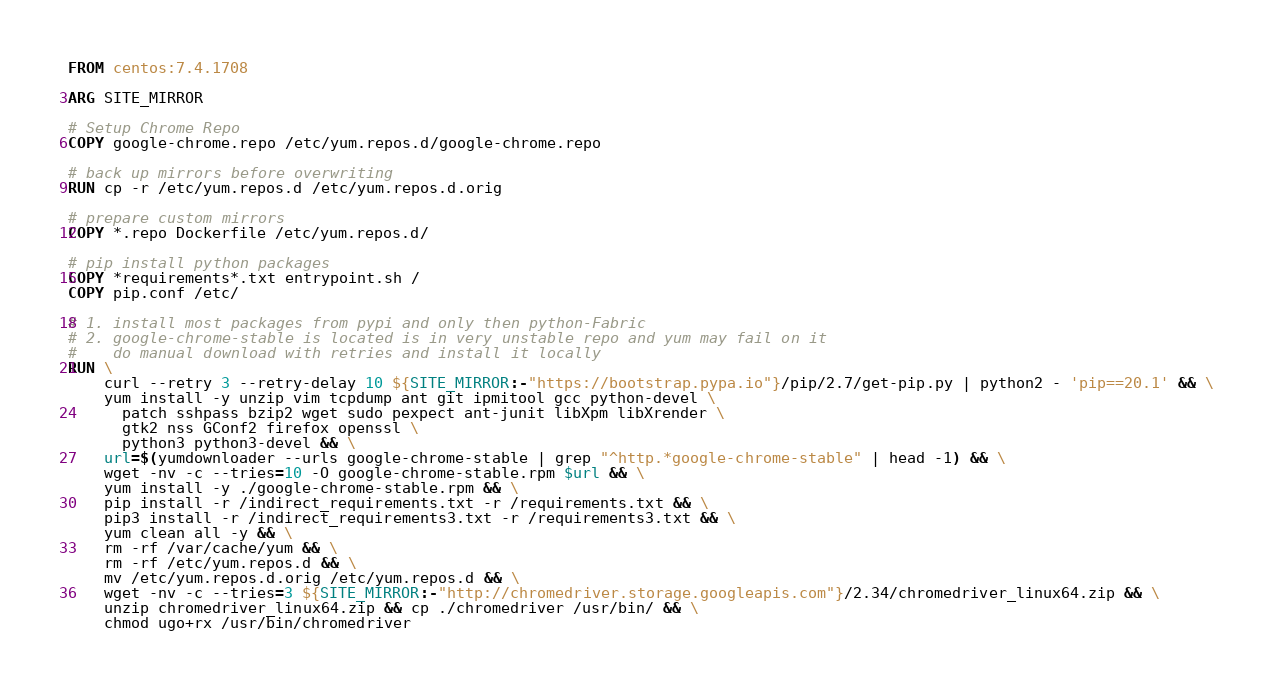<code> <loc_0><loc_0><loc_500><loc_500><_Dockerfile_>FROM centos:7.4.1708

ARG SITE_MIRROR

# Setup Chrome Repo
COPY google-chrome.repo /etc/yum.repos.d/google-chrome.repo

# back up mirrors before overwriting
RUN cp -r /etc/yum.repos.d /etc/yum.repos.d.orig

# prepare custom mirrors
COPY *.repo Dockerfile /etc/yum.repos.d/

# pip install python packages
COPY *requirements*.txt entrypoint.sh /
COPY pip.conf /etc/

# 1. install most packages from pypi and only then python-Fabric
# 2. google-chrome-stable is located is in very unstable repo and yum may fail on it
#    do manual download with retries and install it locally
RUN \
    curl --retry 3 --retry-delay 10 ${SITE_MIRROR:-"https://bootstrap.pypa.io"}/pip/2.7/get-pip.py | python2 - 'pip==20.1' && \
    yum install -y unzip vim tcpdump ant git ipmitool gcc python-devel \
      patch sshpass bzip2 wget sudo pexpect ant-junit libXpm libXrender \
      gtk2 nss GConf2 firefox openssl \
      python3 python3-devel && \
    url=$(yumdownloader --urls google-chrome-stable | grep "^http.*google-chrome-stable" | head -1) && \
    wget -nv -c --tries=10 -O google-chrome-stable.rpm $url && \
    yum install -y ./google-chrome-stable.rpm && \
    pip install -r /indirect_requirements.txt -r /requirements.txt && \
    pip3 install -r /indirect_requirements3.txt -r /requirements3.txt && \
    yum clean all -y && \
    rm -rf /var/cache/yum && \
    rm -rf /etc/yum.repos.d && \
    mv /etc/yum.repos.d.orig /etc/yum.repos.d && \
    wget -nv -c --tries=3 ${SITE_MIRROR:-"http://chromedriver.storage.googleapis.com"}/2.34/chromedriver_linux64.zip && \
    unzip chromedriver_linux64.zip && cp ./chromedriver /usr/bin/ && \
    chmod ugo+rx /usr/bin/chromedriver
</code> 